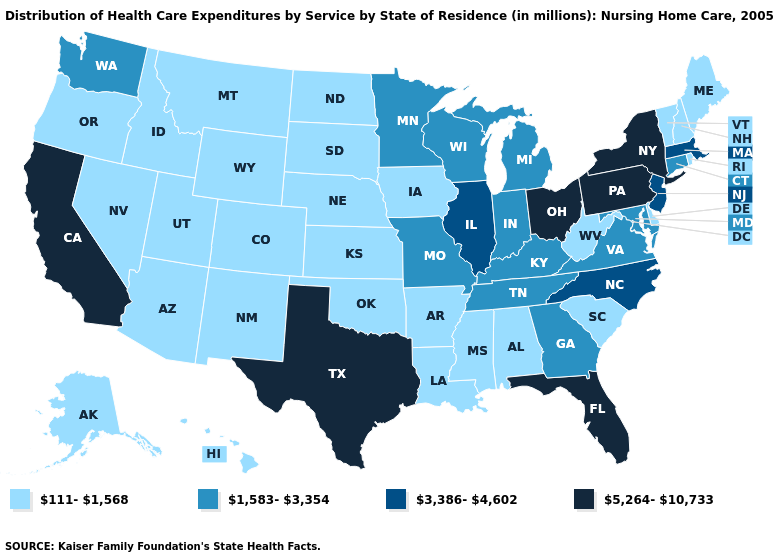Name the states that have a value in the range 1,583-3,354?
Concise answer only. Connecticut, Georgia, Indiana, Kentucky, Maryland, Michigan, Minnesota, Missouri, Tennessee, Virginia, Washington, Wisconsin. What is the value of Idaho?
Give a very brief answer. 111-1,568. Among the states that border Colorado , which have the highest value?
Quick response, please. Arizona, Kansas, Nebraska, New Mexico, Oklahoma, Utah, Wyoming. Does Vermont have a higher value than Pennsylvania?
Give a very brief answer. No. Does the map have missing data?
Give a very brief answer. No. Does Florida have the lowest value in the USA?
Answer briefly. No. Does Minnesota have the lowest value in the USA?
Short answer required. No. Name the states that have a value in the range 1,583-3,354?
Keep it brief. Connecticut, Georgia, Indiana, Kentucky, Maryland, Michigan, Minnesota, Missouri, Tennessee, Virginia, Washington, Wisconsin. Among the states that border Oregon , which have the lowest value?
Concise answer only. Idaho, Nevada. Name the states that have a value in the range 3,386-4,602?
Quick response, please. Illinois, Massachusetts, New Jersey, North Carolina. What is the value of Idaho?
Concise answer only. 111-1,568. Does Kentucky have the highest value in the South?
Be succinct. No. Does the map have missing data?
Answer briefly. No. What is the lowest value in the MidWest?
Keep it brief. 111-1,568. Does the map have missing data?
Be succinct. No. 